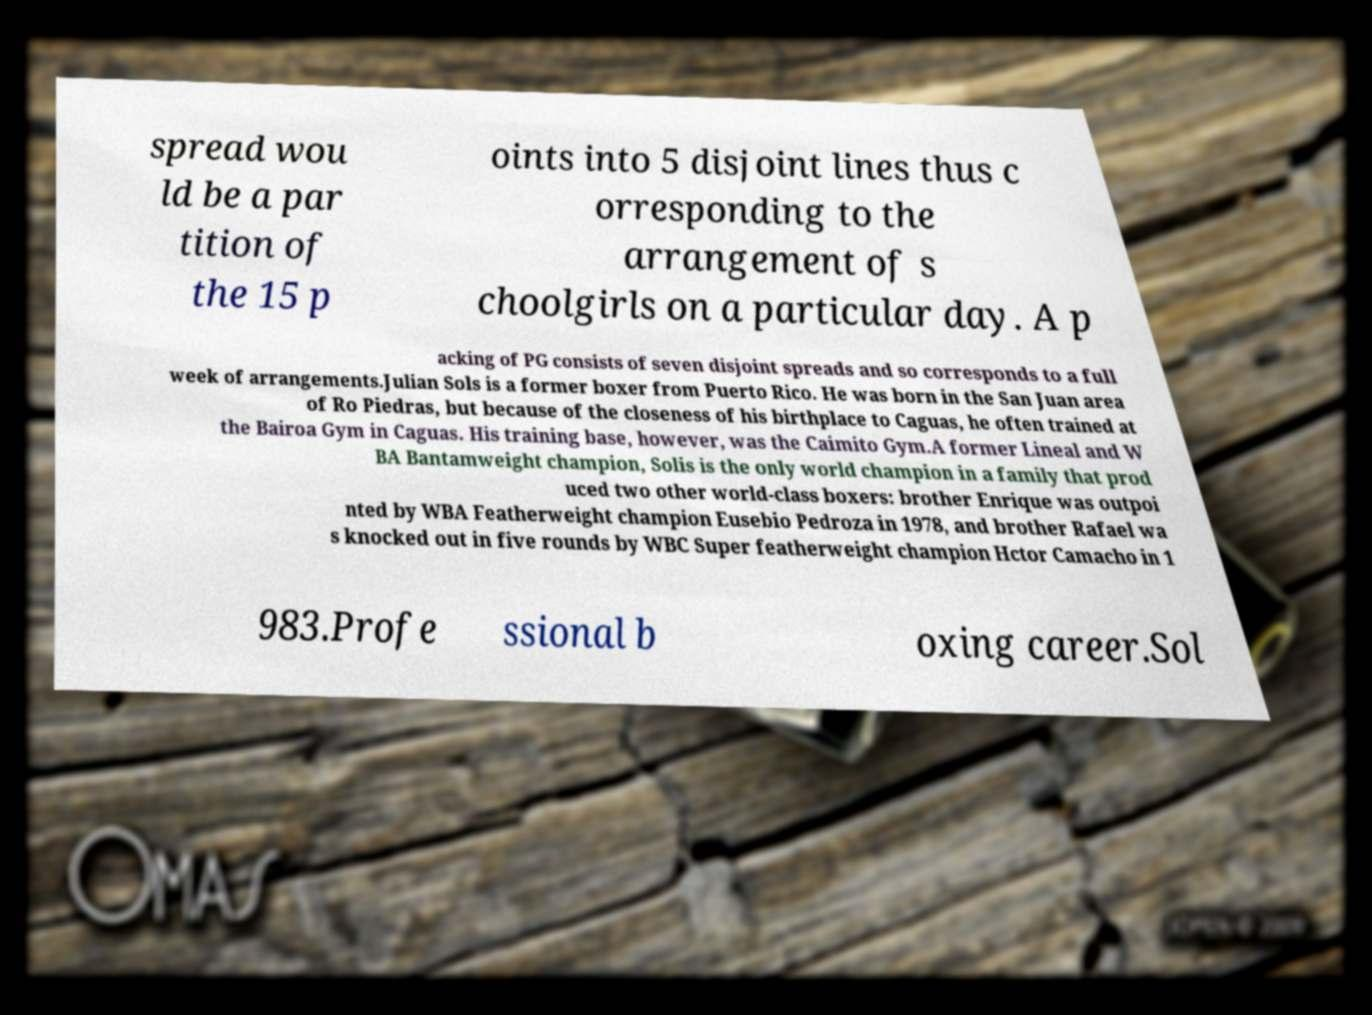Please identify and transcribe the text found in this image. spread wou ld be a par tition of the 15 p oints into 5 disjoint lines thus c orresponding to the arrangement of s choolgirls on a particular day. A p acking of PG consists of seven disjoint spreads and so corresponds to a full week of arrangements.Julian Sols is a former boxer from Puerto Rico. He was born in the San Juan area of Ro Piedras, but because of the closeness of his birthplace to Caguas, he often trained at the Bairoa Gym in Caguas. His training base, however, was the Caimito Gym.A former Lineal and W BA Bantamweight champion, Solis is the only world champion in a family that prod uced two other world-class boxers: brother Enrique was outpoi nted by WBA Featherweight champion Eusebio Pedroza in 1978, and brother Rafael wa s knocked out in five rounds by WBC Super featherweight champion Hctor Camacho in 1 983.Profe ssional b oxing career.Sol 